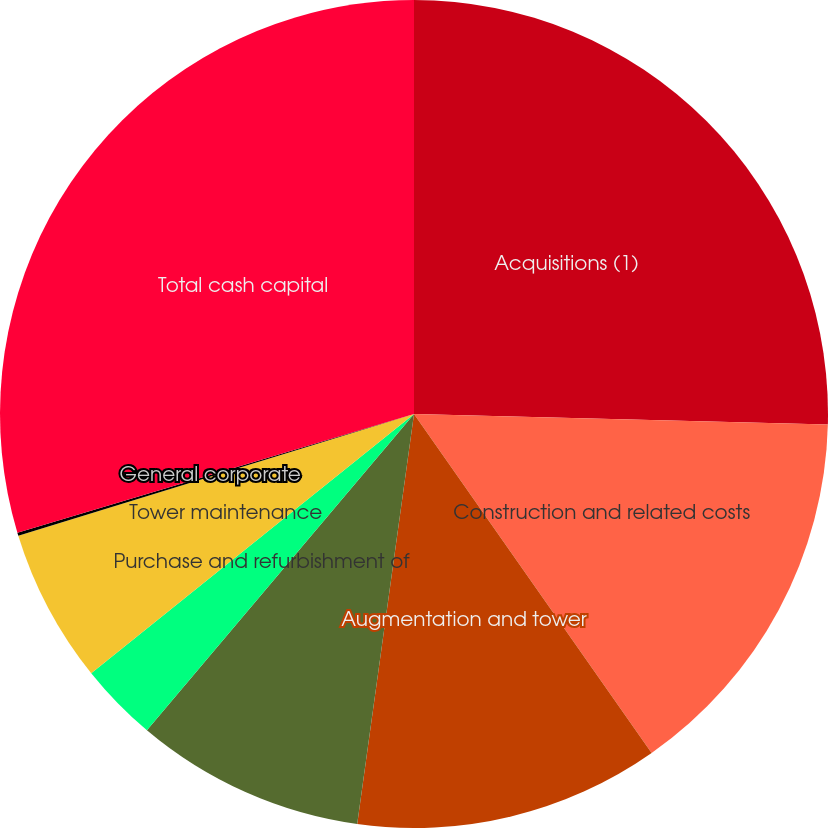<chart> <loc_0><loc_0><loc_500><loc_500><pie_chart><fcel>Acquisitions (1)<fcel>Construction and related costs<fcel>Augmentation and tower<fcel>Land buyouts (2)<fcel>Purchase and refurbishment of<fcel>Tower maintenance<fcel>General corporate<fcel>Total cash capital<nl><fcel>25.4%<fcel>14.87%<fcel>11.92%<fcel>8.97%<fcel>3.07%<fcel>6.02%<fcel>0.12%<fcel>29.63%<nl></chart> 